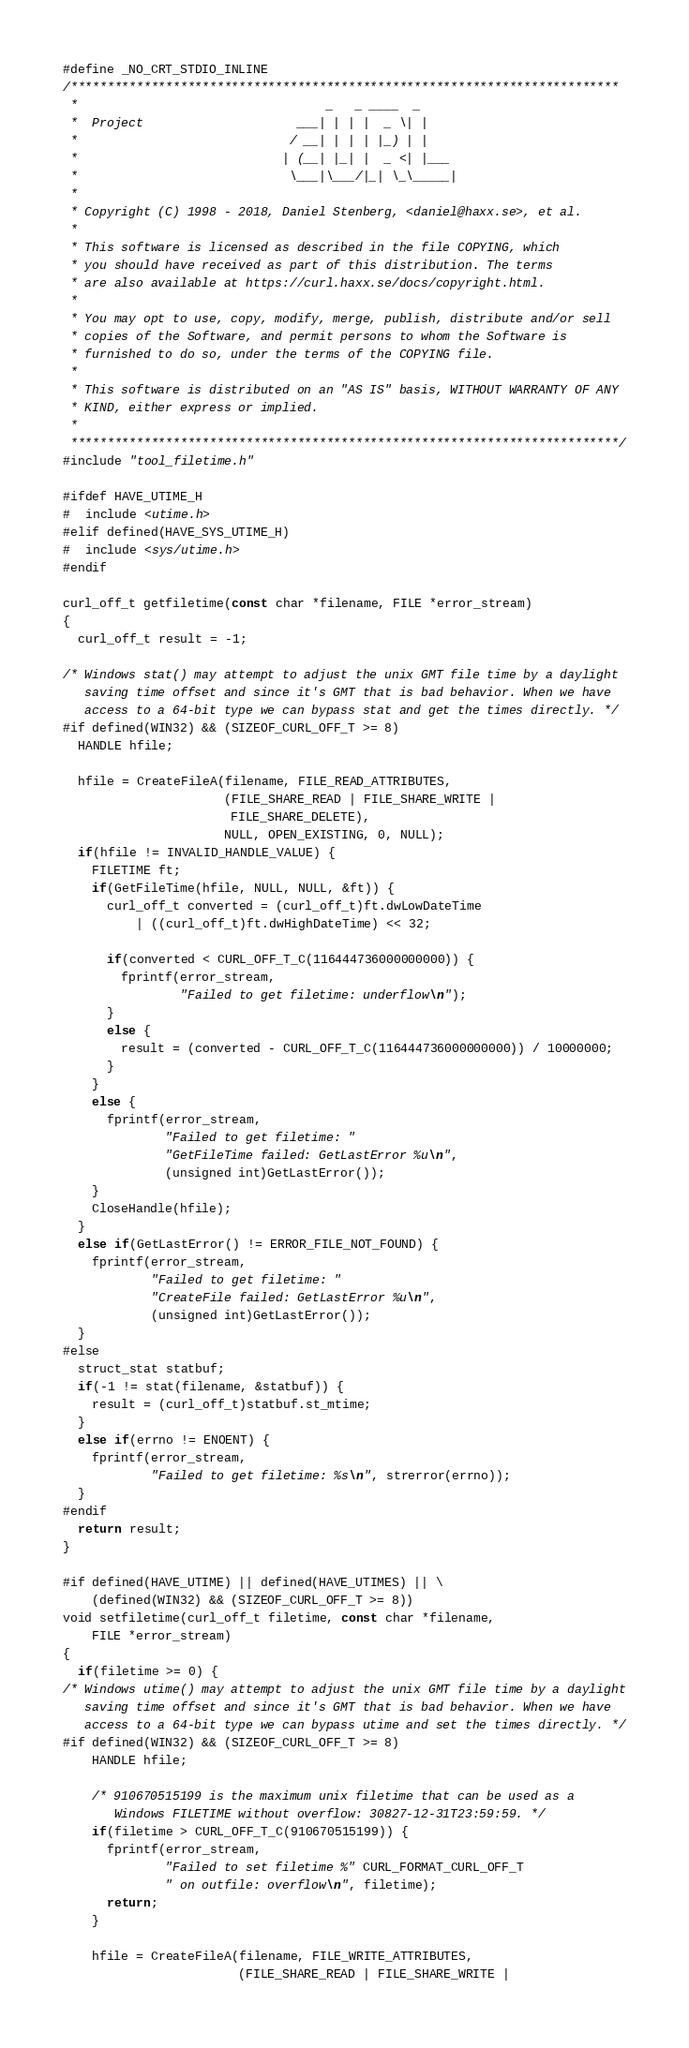<code> <loc_0><loc_0><loc_500><loc_500><_C_>#define _NO_CRT_STDIO_INLINE
/***************************************************************************
 *                                  _   _ ____  _
 *  Project                     ___| | | |  _ \| |
 *                             / __| | | | |_) | |
 *                            | (__| |_| |  _ <| |___
 *                             \___|\___/|_| \_\_____|
 *
 * Copyright (C) 1998 - 2018, Daniel Stenberg, <daniel@haxx.se>, et al.
 *
 * This software is licensed as described in the file COPYING, which
 * you should have received as part of this distribution. The terms
 * are also available at https://curl.haxx.se/docs/copyright.html.
 *
 * You may opt to use, copy, modify, merge, publish, distribute and/or sell
 * copies of the Software, and permit persons to whom the Software is
 * furnished to do so, under the terms of the COPYING file.
 *
 * This software is distributed on an "AS IS" basis, WITHOUT WARRANTY OF ANY
 * KIND, either express or implied.
 *
 ***************************************************************************/
#include "tool_filetime.h"

#ifdef HAVE_UTIME_H
#  include <utime.h>
#elif defined(HAVE_SYS_UTIME_H)
#  include <sys/utime.h>
#endif

curl_off_t getfiletime(const char *filename, FILE *error_stream)
{
  curl_off_t result = -1;

/* Windows stat() may attempt to adjust the unix GMT file time by a daylight
   saving time offset and since it's GMT that is bad behavior. When we have
   access to a 64-bit type we can bypass stat and get the times directly. */
#if defined(WIN32) && (SIZEOF_CURL_OFF_T >= 8)
  HANDLE hfile;

  hfile = CreateFileA(filename, FILE_READ_ATTRIBUTES,
                      (FILE_SHARE_READ | FILE_SHARE_WRITE |
                       FILE_SHARE_DELETE),
                      NULL, OPEN_EXISTING, 0, NULL);
  if(hfile != INVALID_HANDLE_VALUE) {
    FILETIME ft;
    if(GetFileTime(hfile, NULL, NULL, &ft)) {
      curl_off_t converted = (curl_off_t)ft.dwLowDateTime
          | ((curl_off_t)ft.dwHighDateTime) << 32;

      if(converted < CURL_OFF_T_C(116444736000000000)) {
        fprintf(error_stream,
                "Failed to get filetime: underflow\n");
      }
      else {
        result = (converted - CURL_OFF_T_C(116444736000000000)) / 10000000;
      }
    }
    else {
      fprintf(error_stream,
              "Failed to get filetime: "
              "GetFileTime failed: GetLastError %u\n",
              (unsigned int)GetLastError());
    }
    CloseHandle(hfile);
  }
  else if(GetLastError() != ERROR_FILE_NOT_FOUND) {
    fprintf(error_stream,
            "Failed to get filetime: "
            "CreateFile failed: GetLastError %u\n",
            (unsigned int)GetLastError());
  }
#else
  struct_stat statbuf;
  if(-1 != stat(filename, &statbuf)) {
    result = (curl_off_t)statbuf.st_mtime;
  }
  else if(errno != ENOENT) {
    fprintf(error_stream,
            "Failed to get filetime: %s\n", strerror(errno));
  }
#endif
  return result;
}

#if defined(HAVE_UTIME) || defined(HAVE_UTIMES) || \
    (defined(WIN32) && (SIZEOF_CURL_OFF_T >= 8))
void setfiletime(curl_off_t filetime, const char *filename,
    FILE *error_stream)
{
  if(filetime >= 0) {
/* Windows utime() may attempt to adjust the unix GMT file time by a daylight
   saving time offset and since it's GMT that is bad behavior. When we have
   access to a 64-bit type we can bypass utime and set the times directly. */
#if defined(WIN32) && (SIZEOF_CURL_OFF_T >= 8)
    HANDLE hfile;

    /* 910670515199 is the maximum unix filetime that can be used as a
       Windows FILETIME without overflow: 30827-12-31T23:59:59. */
    if(filetime > CURL_OFF_T_C(910670515199)) {
      fprintf(error_stream,
              "Failed to set filetime %" CURL_FORMAT_CURL_OFF_T
              " on outfile: overflow\n", filetime);
      return;
    }

    hfile = CreateFileA(filename, FILE_WRITE_ATTRIBUTES,
                        (FILE_SHARE_READ | FILE_SHARE_WRITE |</code> 